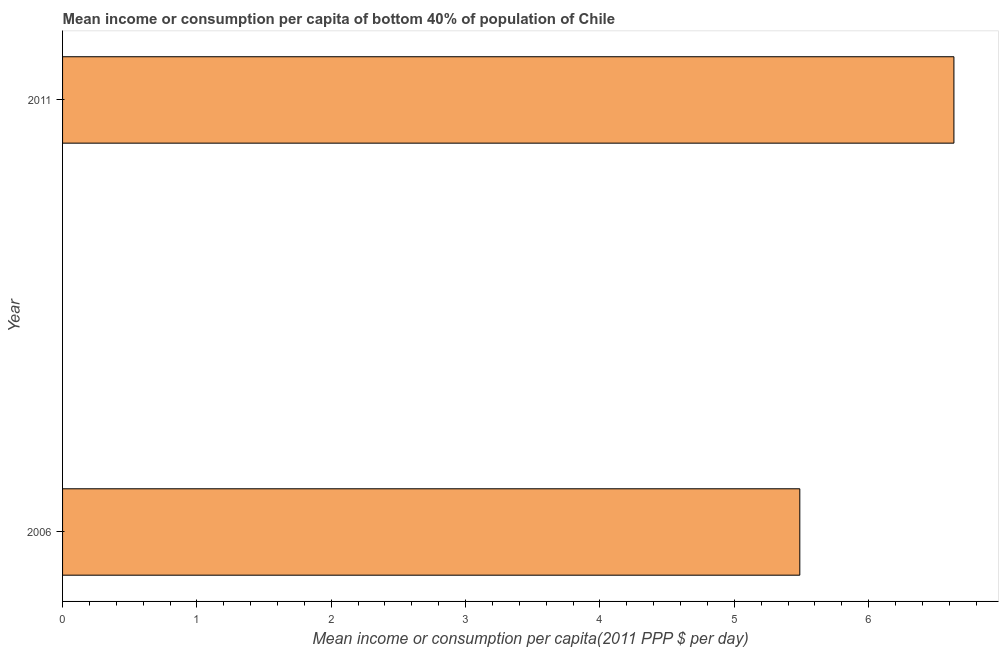What is the title of the graph?
Make the answer very short. Mean income or consumption per capita of bottom 40% of population of Chile. What is the label or title of the X-axis?
Offer a terse response. Mean income or consumption per capita(2011 PPP $ per day). What is the label or title of the Y-axis?
Provide a short and direct response. Year. What is the mean income or consumption in 2006?
Provide a short and direct response. 5.49. Across all years, what is the maximum mean income or consumption?
Your answer should be very brief. 6.63. Across all years, what is the minimum mean income or consumption?
Keep it short and to the point. 5.49. In which year was the mean income or consumption maximum?
Give a very brief answer. 2011. What is the sum of the mean income or consumption?
Provide a short and direct response. 12.12. What is the difference between the mean income or consumption in 2006 and 2011?
Provide a short and direct response. -1.15. What is the average mean income or consumption per year?
Provide a short and direct response. 6.06. What is the median mean income or consumption?
Make the answer very short. 6.06. In how many years, is the mean income or consumption greater than 2 $?
Offer a terse response. 2. What is the ratio of the mean income or consumption in 2006 to that in 2011?
Make the answer very short. 0.83. In how many years, is the mean income or consumption greater than the average mean income or consumption taken over all years?
Keep it short and to the point. 1. How many bars are there?
Offer a terse response. 2. How many years are there in the graph?
Make the answer very short. 2. What is the difference between two consecutive major ticks on the X-axis?
Ensure brevity in your answer.  1. What is the Mean income or consumption per capita(2011 PPP $ per day) of 2006?
Offer a very short reply. 5.49. What is the Mean income or consumption per capita(2011 PPP $ per day) in 2011?
Keep it short and to the point. 6.63. What is the difference between the Mean income or consumption per capita(2011 PPP $ per day) in 2006 and 2011?
Ensure brevity in your answer.  -1.15. What is the ratio of the Mean income or consumption per capita(2011 PPP $ per day) in 2006 to that in 2011?
Ensure brevity in your answer.  0.83. 